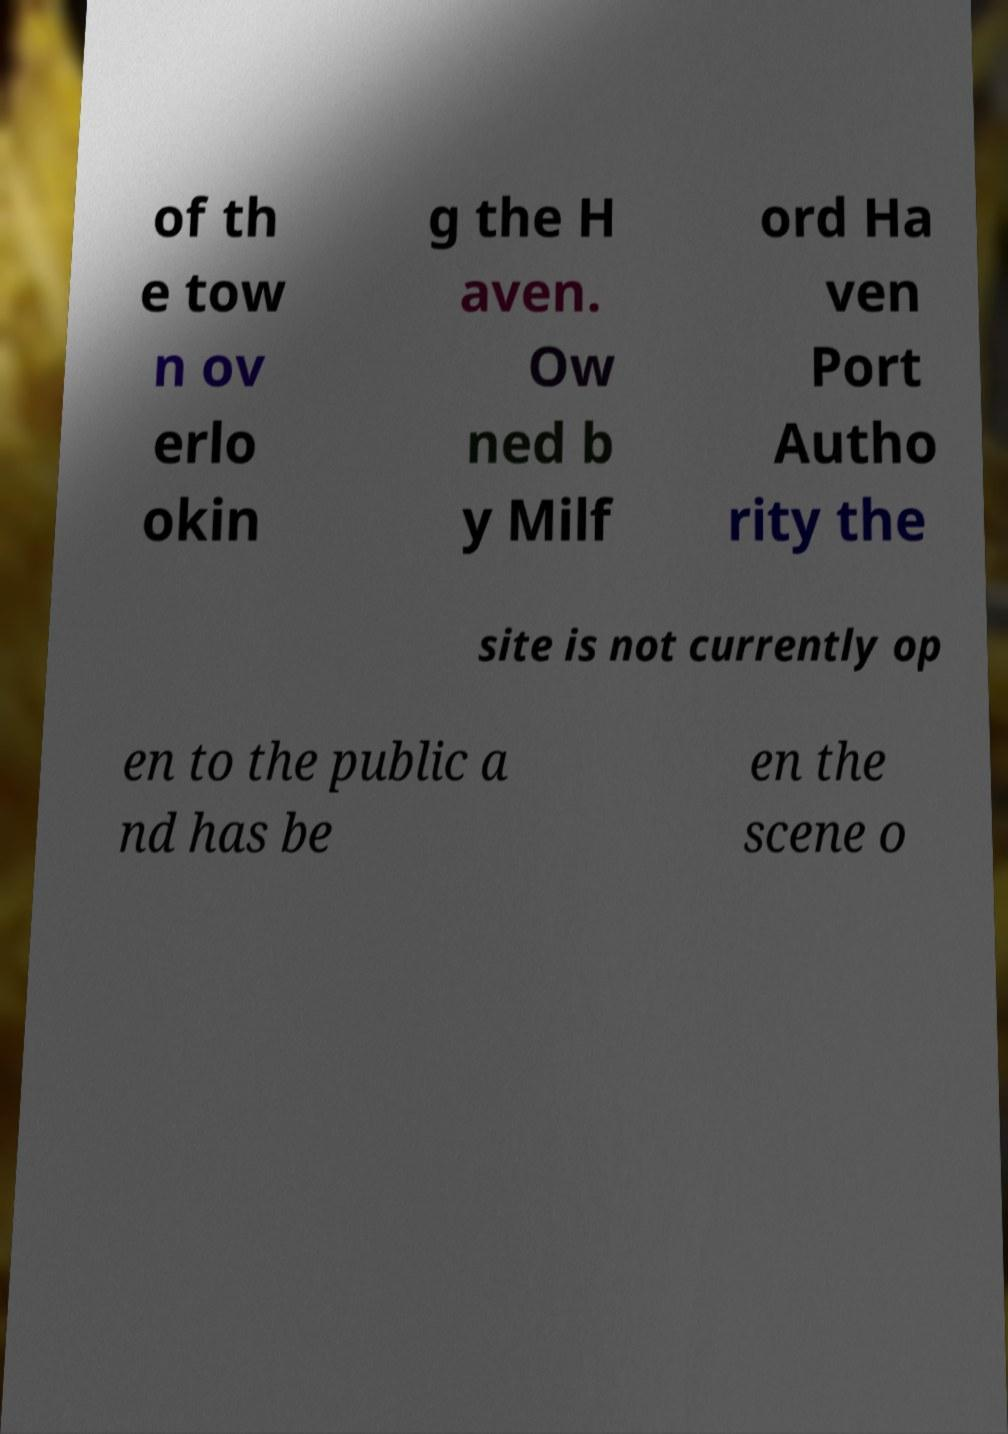Can you read and provide the text displayed in the image?This photo seems to have some interesting text. Can you extract and type it out for me? of th e tow n ov erlo okin g the H aven. Ow ned b y Milf ord Ha ven Port Autho rity the site is not currently op en to the public a nd has be en the scene o 